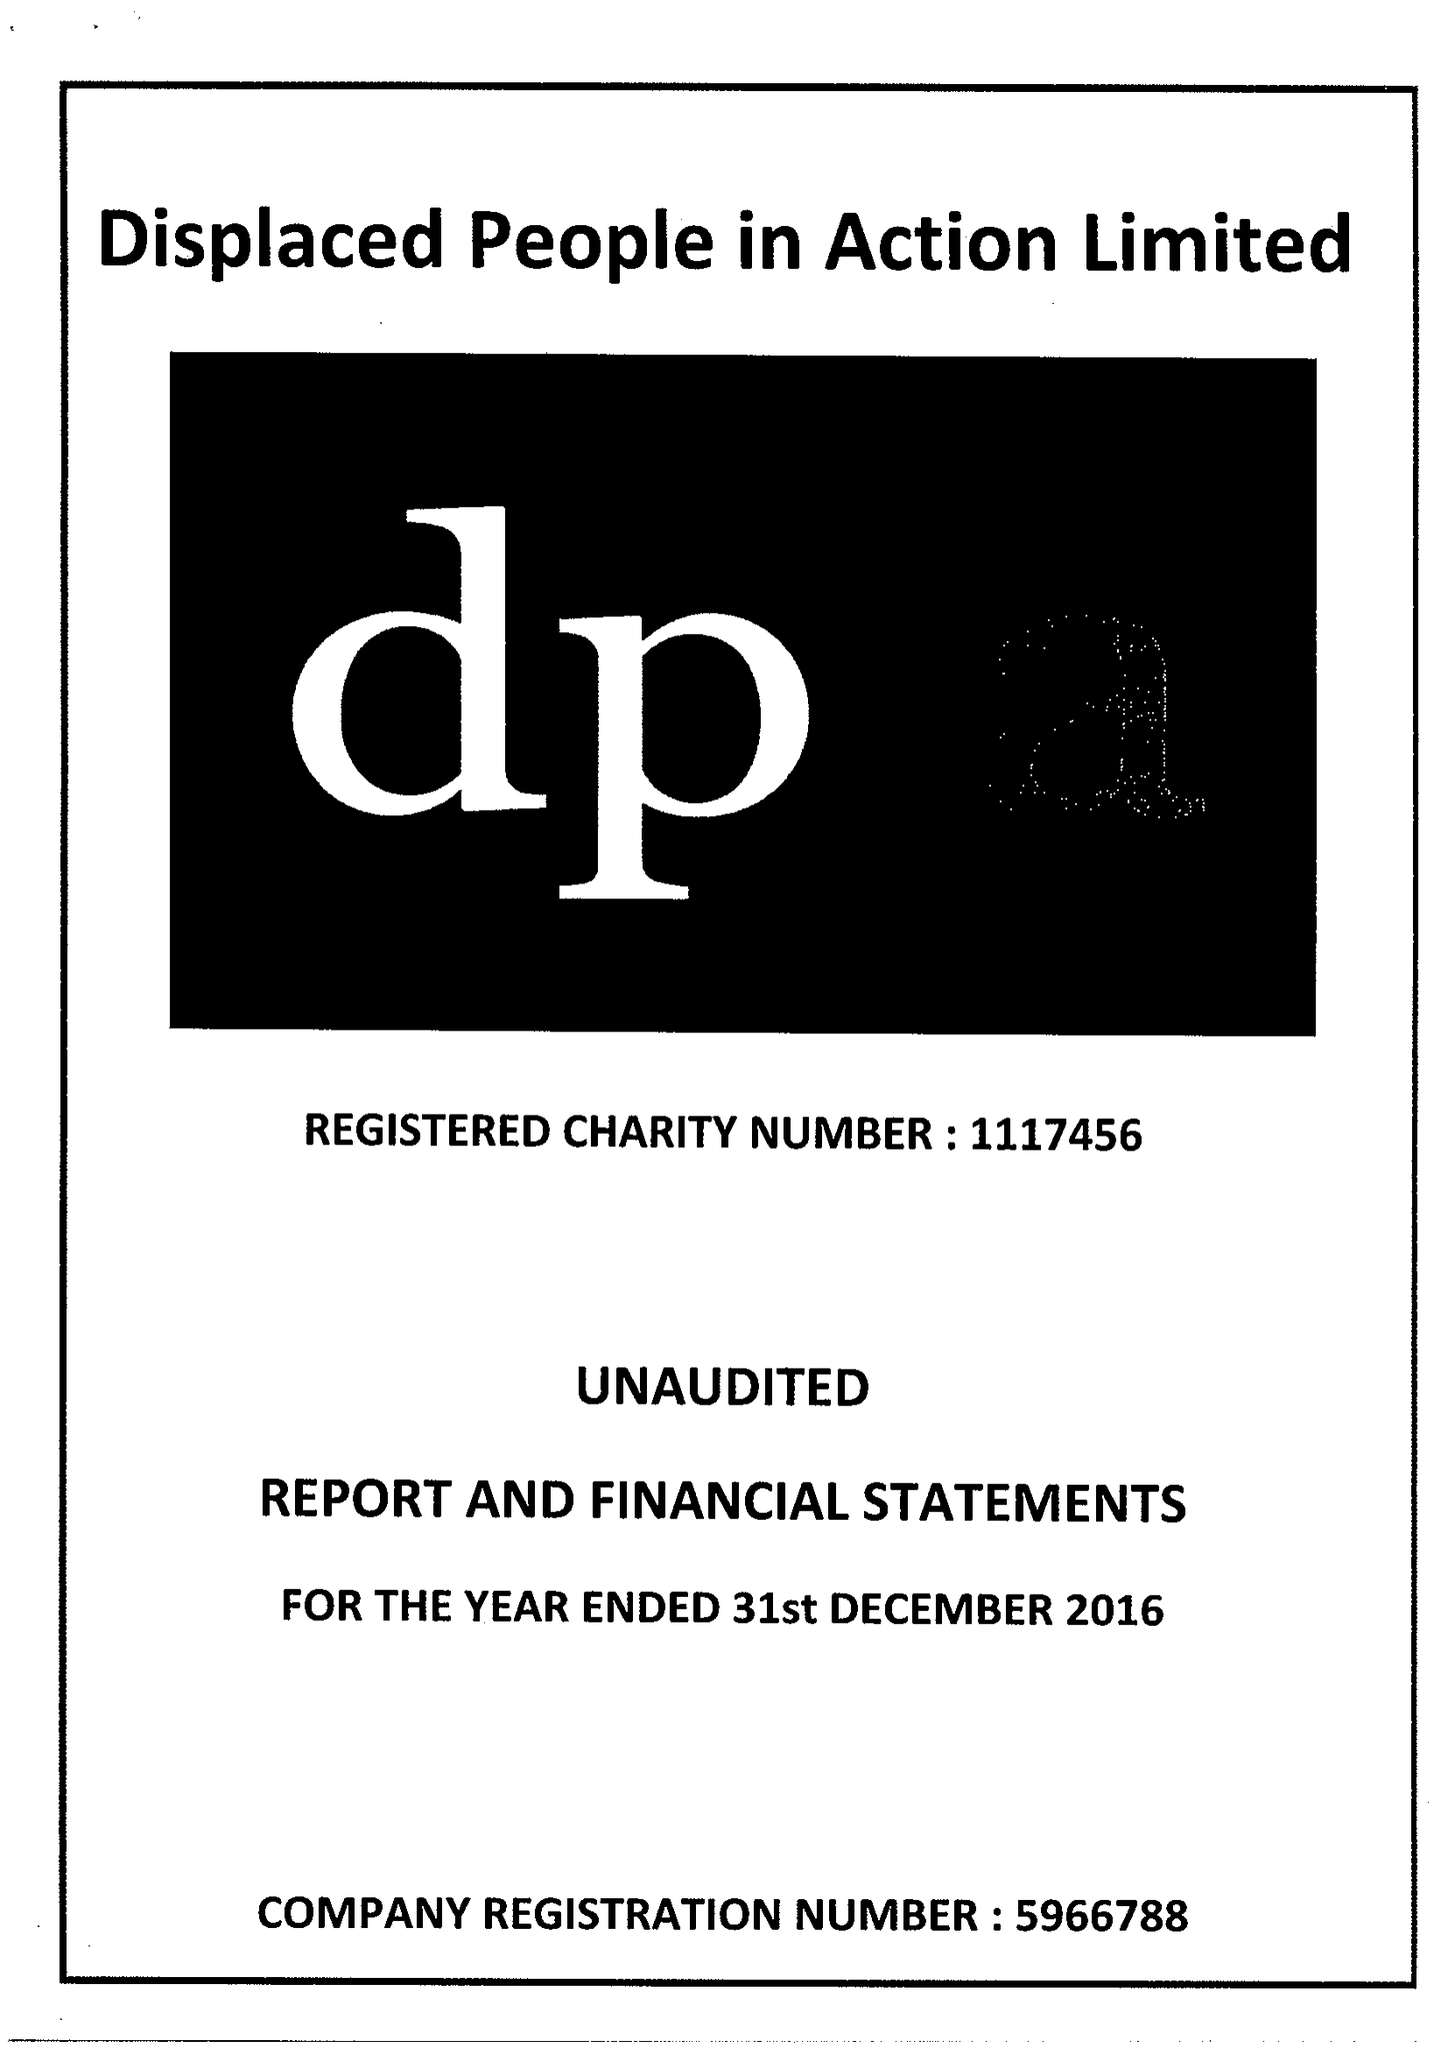What is the value for the charity_number?
Answer the question using a single word or phrase. 1117456 